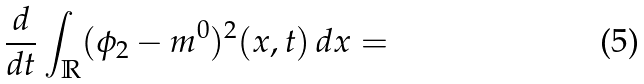<formula> <loc_0><loc_0><loc_500><loc_500>\frac { d } { d t } \int _ { \mathbb { R } } ( \phi _ { 2 } - m ^ { 0 } ) ^ { 2 } ( x , t ) \, d x =</formula> 